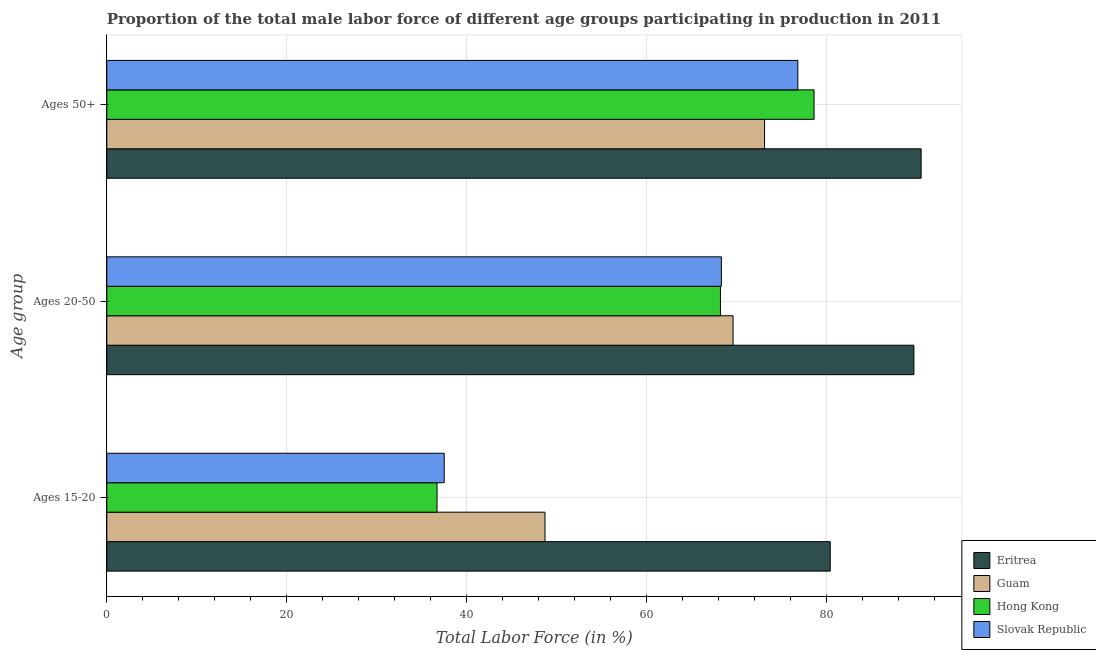How many different coloured bars are there?
Keep it short and to the point. 4. Are the number of bars per tick equal to the number of legend labels?
Offer a terse response. Yes. How many bars are there on the 3rd tick from the top?
Offer a terse response. 4. What is the label of the 2nd group of bars from the top?
Give a very brief answer. Ages 20-50. What is the percentage of male labor force above age 50 in Guam?
Offer a terse response. 73.1. Across all countries, what is the maximum percentage of male labor force within the age group 20-50?
Your answer should be very brief. 89.7. Across all countries, what is the minimum percentage of male labor force within the age group 15-20?
Provide a short and direct response. 36.7. In which country was the percentage of male labor force within the age group 15-20 maximum?
Make the answer very short. Eritrea. In which country was the percentage of male labor force within the age group 20-50 minimum?
Provide a succinct answer. Hong Kong. What is the total percentage of male labor force above age 50 in the graph?
Provide a short and direct response. 319. What is the difference between the percentage of male labor force above age 50 in Eritrea and that in Slovak Republic?
Offer a terse response. 13.7. What is the difference between the percentage of male labor force within the age group 20-50 in Slovak Republic and the percentage of male labor force above age 50 in Eritrea?
Make the answer very short. -22.2. What is the average percentage of male labor force within the age group 20-50 per country?
Provide a succinct answer. 73.95. What is the difference between the percentage of male labor force within the age group 20-50 and percentage of male labor force within the age group 15-20 in Guam?
Ensure brevity in your answer.  20.9. What is the ratio of the percentage of male labor force within the age group 20-50 in Guam to that in Slovak Republic?
Give a very brief answer. 1.02. Is the percentage of male labor force within the age group 20-50 in Eritrea less than that in Guam?
Your response must be concise. No. What is the difference between the highest and the second highest percentage of male labor force above age 50?
Provide a short and direct response. 11.9. What is the difference between the highest and the lowest percentage of male labor force above age 50?
Give a very brief answer. 17.4. In how many countries, is the percentage of male labor force within the age group 20-50 greater than the average percentage of male labor force within the age group 20-50 taken over all countries?
Give a very brief answer. 1. Is the sum of the percentage of male labor force above age 50 in Guam and Eritrea greater than the maximum percentage of male labor force within the age group 15-20 across all countries?
Offer a terse response. Yes. What does the 2nd bar from the top in Ages 15-20 represents?
Ensure brevity in your answer.  Hong Kong. What does the 1st bar from the bottom in Ages 50+ represents?
Your response must be concise. Eritrea. How many bars are there?
Keep it short and to the point. 12. How many countries are there in the graph?
Give a very brief answer. 4. What is the difference between two consecutive major ticks on the X-axis?
Ensure brevity in your answer.  20. Does the graph contain any zero values?
Provide a succinct answer. No. Where does the legend appear in the graph?
Give a very brief answer. Bottom right. How are the legend labels stacked?
Give a very brief answer. Vertical. What is the title of the graph?
Give a very brief answer. Proportion of the total male labor force of different age groups participating in production in 2011. Does "Czech Republic" appear as one of the legend labels in the graph?
Offer a terse response. No. What is the label or title of the Y-axis?
Ensure brevity in your answer.  Age group. What is the Total Labor Force (in %) in Eritrea in Ages 15-20?
Offer a very short reply. 80.4. What is the Total Labor Force (in %) of Guam in Ages 15-20?
Your answer should be very brief. 48.7. What is the Total Labor Force (in %) in Hong Kong in Ages 15-20?
Give a very brief answer. 36.7. What is the Total Labor Force (in %) of Slovak Republic in Ages 15-20?
Your response must be concise. 37.5. What is the Total Labor Force (in %) of Eritrea in Ages 20-50?
Your response must be concise. 89.7. What is the Total Labor Force (in %) in Guam in Ages 20-50?
Make the answer very short. 69.6. What is the Total Labor Force (in %) of Hong Kong in Ages 20-50?
Offer a terse response. 68.2. What is the Total Labor Force (in %) in Slovak Republic in Ages 20-50?
Provide a short and direct response. 68.3. What is the Total Labor Force (in %) in Eritrea in Ages 50+?
Make the answer very short. 90.5. What is the Total Labor Force (in %) in Guam in Ages 50+?
Offer a terse response. 73.1. What is the Total Labor Force (in %) in Hong Kong in Ages 50+?
Your answer should be compact. 78.6. What is the Total Labor Force (in %) in Slovak Republic in Ages 50+?
Make the answer very short. 76.8. Across all Age group, what is the maximum Total Labor Force (in %) in Eritrea?
Offer a terse response. 90.5. Across all Age group, what is the maximum Total Labor Force (in %) in Guam?
Offer a terse response. 73.1. Across all Age group, what is the maximum Total Labor Force (in %) of Hong Kong?
Give a very brief answer. 78.6. Across all Age group, what is the maximum Total Labor Force (in %) of Slovak Republic?
Your response must be concise. 76.8. Across all Age group, what is the minimum Total Labor Force (in %) in Eritrea?
Ensure brevity in your answer.  80.4. Across all Age group, what is the minimum Total Labor Force (in %) in Guam?
Provide a succinct answer. 48.7. Across all Age group, what is the minimum Total Labor Force (in %) of Hong Kong?
Your response must be concise. 36.7. Across all Age group, what is the minimum Total Labor Force (in %) of Slovak Republic?
Offer a terse response. 37.5. What is the total Total Labor Force (in %) in Eritrea in the graph?
Your answer should be compact. 260.6. What is the total Total Labor Force (in %) of Guam in the graph?
Your response must be concise. 191.4. What is the total Total Labor Force (in %) of Hong Kong in the graph?
Provide a succinct answer. 183.5. What is the total Total Labor Force (in %) of Slovak Republic in the graph?
Offer a very short reply. 182.6. What is the difference between the Total Labor Force (in %) of Guam in Ages 15-20 and that in Ages 20-50?
Provide a succinct answer. -20.9. What is the difference between the Total Labor Force (in %) of Hong Kong in Ages 15-20 and that in Ages 20-50?
Your response must be concise. -31.5. What is the difference between the Total Labor Force (in %) of Slovak Republic in Ages 15-20 and that in Ages 20-50?
Provide a short and direct response. -30.8. What is the difference between the Total Labor Force (in %) in Eritrea in Ages 15-20 and that in Ages 50+?
Offer a terse response. -10.1. What is the difference between the Total Labor Force (in %) in Guam in Ages 15-20 and that in Ages 50+?
Offer a very short reply. -24.4. What is the difference between the Total Labor Force (in %) in Hong Kong in Ages 15-20 and that in Ages 50+?
Give a very brief answer. -41.9. What is the difference between the Total Labor Force (in %) of Slovak Republic in Ages 15-20 and that in Ages 50+?
Your response must be concise. -39.3. What is the difference between the Total Labor Force (in %) of Eritrea in Ages 20-50 and that in Ages 50+?
Your answer should be compact. -0.8. What is the difference between the Total Labor Force (in %) of Guam in Ages 20-50 and that in Ages 50+?
Ensure brevity in your answer.  -3.5. What is the difference between the Total Labor Force (in %) of Hong Kong in Ages 20-50 and that in Ages 50+?
Make the answer very short. -10.4. What is the difference between the Total Labor Force (in %) of Guam in Ages 15-20 and the Total Labor Force (in %) of Hong Kong in Ages 20-50?
Offer a terse response. -19.5. What is the difference between the Total Labor Force (in %) of Guam in Ages 15-20 and the Total Labor Force (in %) of Slovak Republic in Ages 20-50?
Provide a succinct answer. -19.6. What is the difference between the Total Labor Force (in %) of Hong Kong in Ages 15-20 and the Total Labor Force (in %) of Slovak Republic in Ages 20-50?
Offer a very short reply. -31.6. What is the difference between the Total Labor Force (in %) of Eritrea in Ages 15-20 and the Total Labor Force (in %) of Guam in Ages 50+?
Provide a succinct answer. 7.3. What is the difference between the Total Labor Force (in %) of Eritrea in Ages 15-20 and the Total Labor Force (in %) of Slovak Republic in Ages 50+?
Provide a short and direct response. 3.6. What is the difference between the Total Labor Force (in %) of Guam in Ages 15-20 and the Total Labor Force (in %) of Hong Kong in Ages 50+?
Keep it short and to the point. -29.9. What is the difference between the Total Labor Force (in %) in Guam in Ages 15-20 and the Total Labor Force (in %) in Slovak Republic in Ages 50+?
Offer a very short reply. -28.1. What is the difference between the Total Labor Force (in %) in Hong Kong in Ages 15-20 and the Total Labor Force (in %) in Slovak Republic in Ages 50+?
Your answer should be very brief. -40.1. What is the difference between the Total Labor Force (in %) of Eritrea in Ages 20-50 and the Total Labor Force (in %) of Hong Kong in Ages 50+?
Your response must be concise. 11.1. What is the difference between the Total Labor Force (in %) in Guam in Ages 20-50 and the Total Labor Force (in %) in Hong Kong in Ages 50+?
Ensure brevity in your answer.  -9. What is the difference between the Total Labor Force (in %) in Guam in Ages 20-50 and the Total Labor Force (in %) in Slovak Republic in Ages 50+?
Your answer should be very brief. -7.2. What is the difference between the Total Labor Force (in %) in Hong Kong in Ages 20-50 and the Total Labor Force (in %) in Slovak Republic in Ages 50+?
Your response must be concise. -8.6. What is the average Total Labor Force (in %) in Eritrea per Age group?
Ensure brevity in your answer.  86.87. What is the average Total Labor Force (in %) in Guam per Age group?
Provide a short and direct response. 63.8. What is the average Total Labor Force (in %) in Hong Kong per Age group?
Provide a succinct answer. 61.17. What is the average Total Labor Force (in %) of Slovak Republic per Age group?
Provide a short and direct response. 60.87. What is the difference between the Total Labor Force (in %) of Eritrea and Total Labor Force (in %) of Guam in Ages 15-20?
Keep it short and to the point. 31.7. What is the difference between the Total Labor Force (in %) of Eritrea and Total Labor Force (in %) of Hong Kong in Ages 15-20?
Your answer should be compact. 43.7. What is the difference between the Total Labor Force (in %) in Eritrea and Total Labor Force (in %) in Slovak Republic in Ages 15-20?
Provide a short and direct response. 42.9. What is the difference between the Total Labor Force (in %) of Eritrea and Total Labor Force (in %) of Guam in Ages 20-50?
Give a very brief answer. 20.1. What is the difference between the Total Labor Force (in %) in Eritrea and Total Labor Force (in %) in Hong Kong in Ages 20-50?
Your response must be concise. 21.5. What is the difference between the Total Labor Force (in %) in Eritrea and Total Labor Force (in %) in Slovak Republic in Ages 20-50?
Provide a short and direct response. 21.4. What is the difference between the Total Labor Force (in %) of Guam and Total Labor Force (in %) of Hong Kong in Ages 20-50?
Your answer should be compact. 1.4. What is the difference between the Total Labor Force (in %) in Eritrea and Total Labor Force (in %) in Guam in Ages 50+?
Your response must be concise. 17.4. What is the difference between the Total Labor Force (in %) in Eritrea and Total Labor Force (in %) in Slovak Republic in Ages 50+?
Offer a terse response. 13.7. What is the difference between the Total Labor Force (in %) in Guam and Total Labor Force (in %) in Hong Kong in Ages 50+?
Ensure brevity in your answer.  -5.5. What is the ratio of the Total Labor Force (in %) in Eritrea in Ages 15-20 to that in Ages 20-50?
Make the answer very short. 0.9. What is the ratio of the Total Labor Force (in %) of Guam in Ages 15-20 to that in Ages 20-50?
Give a very brief answer. 0.7. What is the ratio of the Total Labor Force (in %) of Hong Kong in Ages 15-20 to that in Ages 20-50?
Offer a very short reply. 0.54. What is the ratio of the Total Labor Force (in %) in Slovak Republic in Ages 15-20 to that in Ages 20-50?
Your answer should be very brief. 0.55. What is the ratio of the Total Labor Force (in %) in Eritrea in Ages 15-20 to that in Ages 50+?
Provide a short and direct response. 0.89. What is the ratio of the Total Labor Force (in %) of Guam in Ages 15-20 to that in Ages 50+?
Keep it short and to the point. 0.67. What is the ratio of the Total Labor Force (in %) in Hong Kong in Ages 15-20 to that in Ages 50+?
Offer a terse response. 0.47. What is the ratio of the Total Labor Force (in %) in Slovak Republic in Ages 15-20 to that in Ages 50+?
Your answer should be compact. 0.49. What is the ratio of the Total Labor Force (in %) of Guam in Ages 20-50 to that in Ages 50+?
Your answer should be very brief. 0.95. What is the ratio of the Total Labor Force (in %) in Hong Kong in Ages 20-50 to that in Ages 50+?
Your answer should be compact. 0.87. What is the ratio of the Total Labor Force (in %) of Slovak Republic in Ages 20-50 to that in Ages 50+?
Offer a very short reply. 0.89. What is the difference between the highest and the second highest Total Labor Force (in %) of Eritrea?
Your answer should be compact. 0.8. What is the difference between the highest and the second highest Total Labor Force (in %) in Guam?
Your answer should be very brief. 3.5. What is the difference between the highest and the second highest Total Labor Force (in %) in Slovak Republic?
Provide a succinct answer. 8.5. What is the difference between the highest and the lowest Total Labor Force (in %) in Eritrea?
Offer a terse response. 10.1. What is the difference between the highest and the lowest Total Labor Force (in %) in Guam?
Provide a succinct answer. 24.4. What is the difference between the highest and the lowest Total Labor Force (in %) of Hong Kong?
Offer a terse response. 41.9. What is the difference between the highest and the lowest Total Labor Force (in %) of Slovak Republic?
Your answer should be compact. 39.3. 